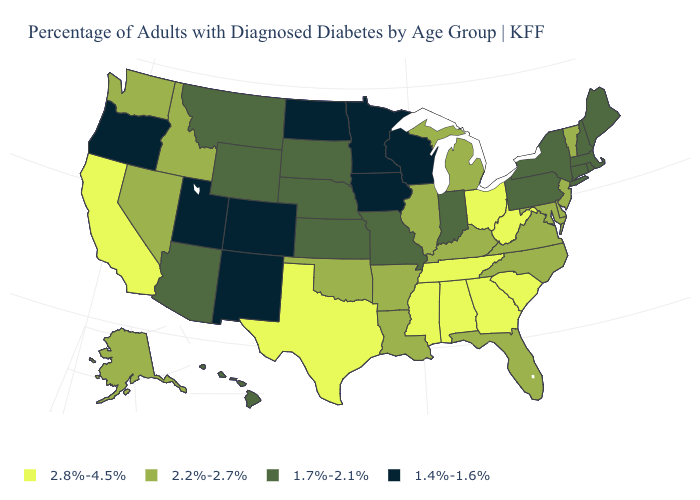What is the value of North Carolina?
Answer briefly. 2.2%-2.7%. How many symbols are there in the legend?
Short answer required. 4. Which states have the lowest value in the USA?
Write a very short answer. Colorado, Iowa, Minnesota, New Mexico, North Dakota, Oregon, Utah, Wisconsin. Does Mississippi have the highest value in the USA?
Be succinct. Yes. Is the legend a continuous bar?
Concise answer only. No. What is the value of Wisconsin?
Concise answer only. 1.4%-1.6%. Name the states that have a value in the range 2.8%-4.5%?
Concise answer only. Alabama, California, Georgia, Mississippi, Ohio, South Carolina, Tennessee, Texas, West Virginia. Name the states that have a value in the range 2.8%-4.5%?
Give a very brief answer. Alabama, California, Georgia, Mississippi, Ohio, South Carolina, Tennessee, Texas, West Virginia. Does Montana have a higher value than Vermont?
Keep it brief. No. What is the lowest value in the USA?
Short answer required. 1.4%-1.6%. What is the value of Arkansas?
Give a very brief answer. 2.2%-2.7%. Name the states that have a value in the range 2.2%-2.7%?
Write a very short answer. Alaska, Arkansas, Delaware, Florida, Idaho, Illinois, Kentucky, Louisiana, Maryland, Michigan, Nevada, New Jersey, North Carolina, Oklahoma, Vermont, Virginia, Washington. Does Hawaii have a lower value than South Carolina?
Write a very short answer. Yes. What is the lowest value in states that border South Carolina?
Keep it brief. 2.2%-2.7%. Among the states that border North Carolina , which have the highest value?
Write a very short answer. Georgia, South Carolina, Tennessee. 